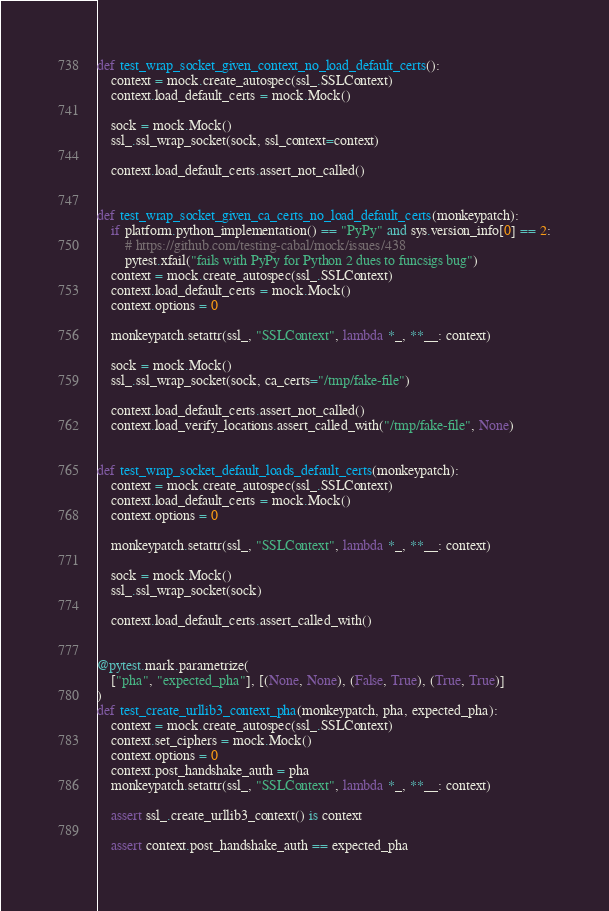<code> <loc_0><loc_0><loc_500><loc_500><_Python_>

def test_wrap_socket_given_context_no_load_default_certs():
    context = mock.create_autospec(ssl_.SSLContext)
    context.load_default_certs = mock.Mock()

    sock = mock.Mock()
    ssl_.ssl_wrap_socket(sock, ssl_context=context)

    context.load_default_certs.assert_not_called()


def test_wrap_socket_given_ca_certs_no_load_default_certs(monkeypatch):
    if platform.python_implementation() == "PyPy" and sys.version_info[0] == 2:
        # https://github.com/testing-cabal/mock/issues/438
        pytest.xfail("fails with PyPy for Python 2 dues to funcsigs bug")
    context = mock.create_autospec(ssl_.SSLContext)
    context.load_default_certs = mock.Mock()
    context.options = 0

    monkeypatch.setattr(ssl_, "SSLContext", lambda *_, **__: context)

    sock = mock.Mock()
    ssl_.ssl_wrap_socket(sock, ca_certs="/tmp/fake-file")

    context.load_default_certs.assert_not_called()
    context.load_verify_locations.assert_called_with("/tmp/fake-file", None)


def test_wrap_socket_default_loads_default_certs(monkeypatch):
    context = mock.create_autospec(ssl_.SSLContext)
    context.load_default_certs = mock.Mock()
    context.options = 0

    monkeypatch.setattr(ssl_, "SSLContext", lambda *_, **__: context)

    sock = mock.Mock()
    ssl_.ssl_wrap_socket(sock)

    context.load_default_certs.assert_called_with()


@pytest.mark.parametrize(
    ["pha", "expected_pha"], [(None, None), (False, True), (True, True)]
)
def test_create_urllib3_context_pha(monkeypatch, pha, expected_pha):
    context = mock.create_autospec(ssl_.SSLContext)
    context.set_ciphers = mock.Mock()
    context.options = 0
    context.post_handshake_auth = pha
    monkeypatch.setattr(ssl_, "SSLContext", lambda *_, **__: context)

    assert ssl_.create_urllib3_context() is context

    assert context.post_handshake_auth == expected_pha
</code> 